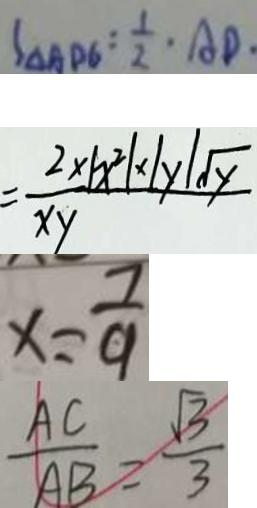Convert formula to latex. <formula><loc_0><loc_0><loc_500><loc_500>S _ { \Delta A D G } = \frac { 1 } { 2 } \cdot A D \cdot 
 = \frac { 2 \times \vert x ^ { 2 } \vert y \vert \sqrt { y } } { x y } 
 x = \frac { 7 } { 9 } 
 \frac { A C } { A B } = \frac { \sqrt { 3 } } { 3 }</formula> 